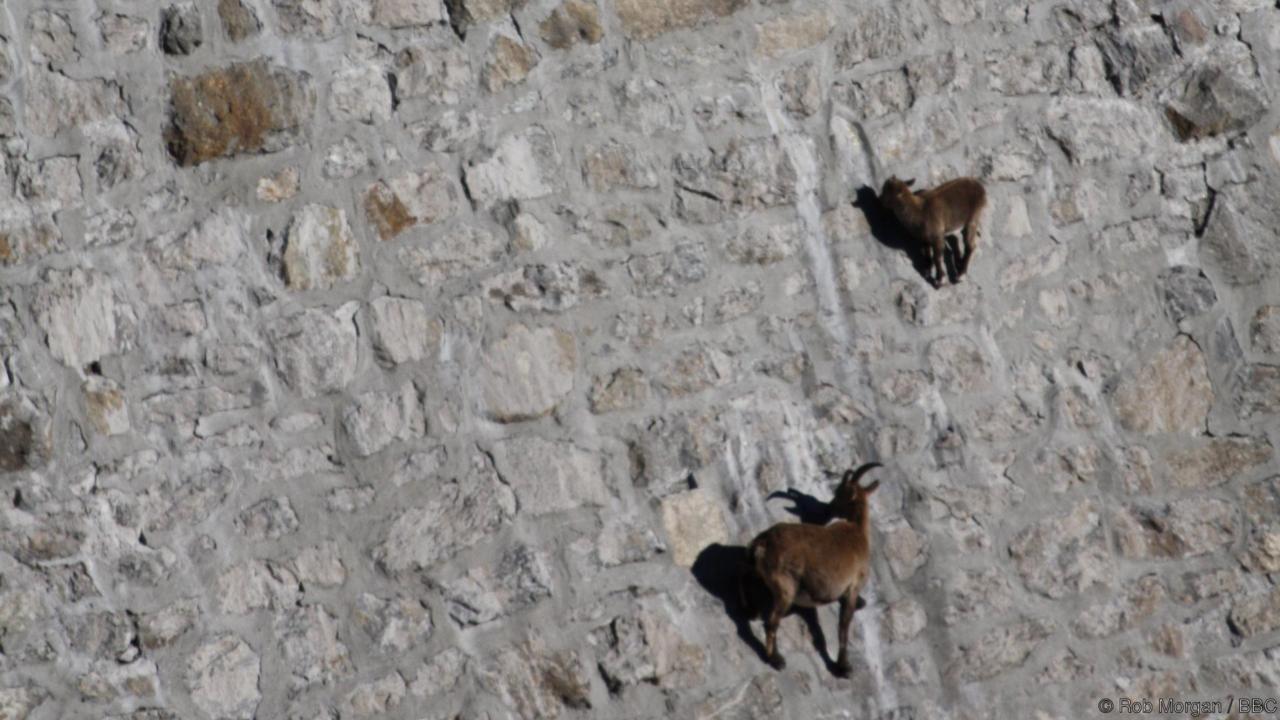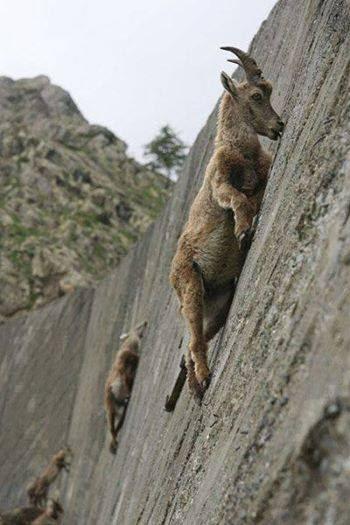The first image is the image on the left, the second image is the image on the right. Analyze the images presented: Is the assertion "At least one image in each pair has exactly three animals together on a wall." valid? Answer yes or no. No. 